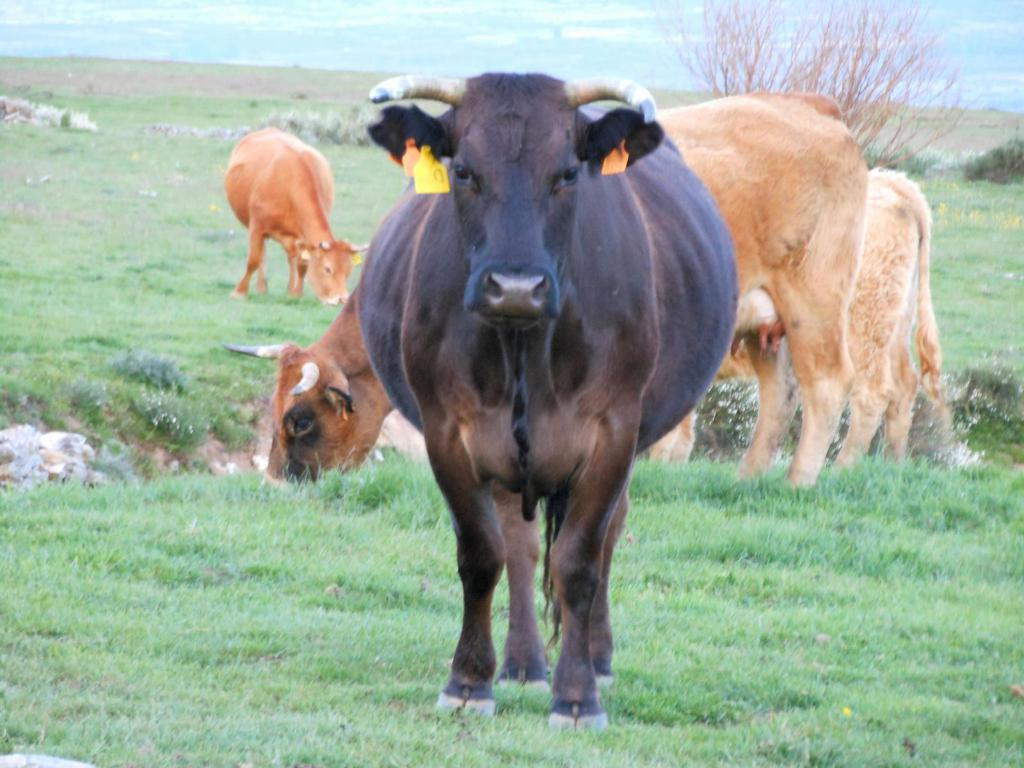What type of animal is in the image? There is a black cow in the image. Where is the black cow located? The black cow is on the grass. What are the other cows in the image doing? The cows are grazing in the background. What is the terrain like where the cows are located? The cows are on the grass. What can be seen in the background of the image? There is sky and a tree visible in the background. What store can be seen in the background of the image? There is no store present in the image; it features cows grazing on grass with a tree and sky visible in the background. 